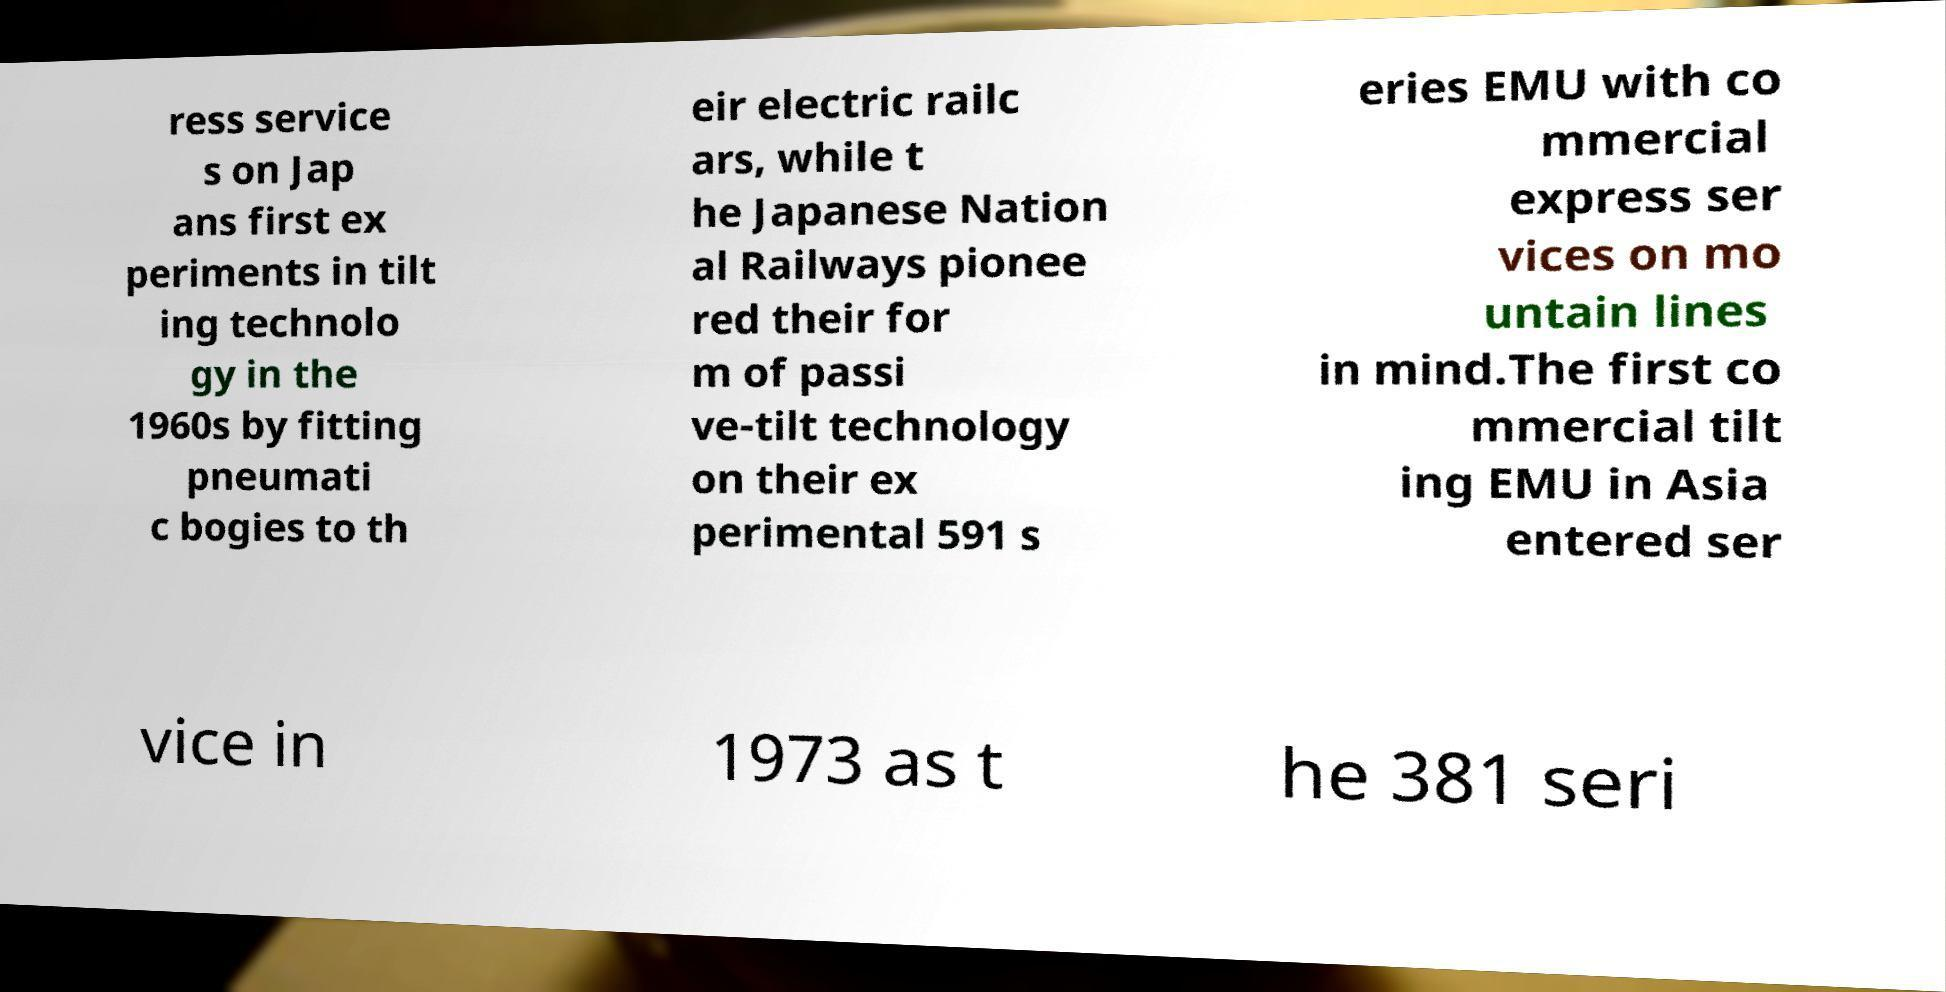Could you assist in decoding the text presented in this image and type it out clearly? ress service s on Jap ans first ex periments in tilt ing technolo gy in the 1960s by fitting pneumati c bogies to th eir electric railc ars, while t he Japanese Nation al Railways pionee red their for m of passi ve-tilt technology on their ex perimental 591 s eries EMU with co mmercial express ser vices on mo untain lines in mind.The first co mmercial tilt ing EMU in Asia entered ser vice in 1973 as t he 381 seri 